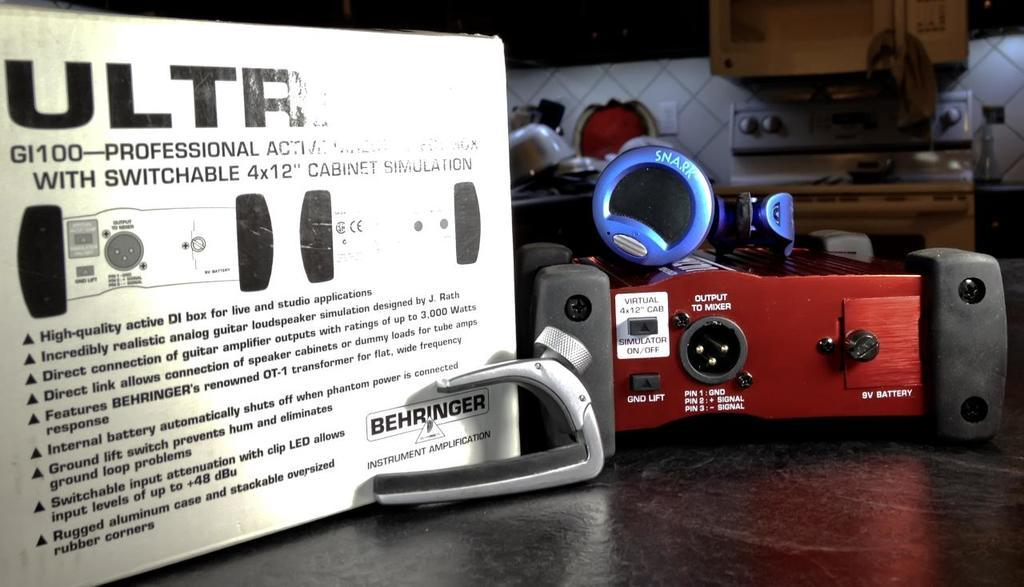<image>
Summarize the visual content of the image. A white Behringer instrument amplification device in a kitchen 